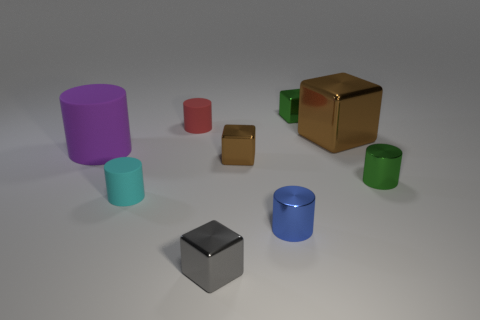What shape is the small metallic thing that is the same color as the big shiny cube?
Your response must be concise. Cube. How many cyan rubber things are the same size as the green cylinder?
Give a very brief answer. 1. Does the thing that is behind the red matte thing have the same size as the tiny cyan object?
Your answer should be compact. Yes. What shape is the tiny object that is left of the blue metallic cylinder and in front of the small cyan rubber object?
Your answer should be compact. Cube. There is a tiny brown metal object; are there any big brown things in front of it?
Ensure brevity in your answer.  No. Is there anything else that has the same shape as the small red thing?
Offer a terse response. Yes. Is the shape of the big brown object the same as the gray thing?
Make the answer very short. Yes. Are there the same number of tiny gray metallic cubes that are behind the cyan object and small brown metallic blocks that are left of the purple rubber cylinder?
Ensure brevity in your answer.  Yes. How many other things are there of the same material as the tiny blue cylinder?
Offer a terse response. 5. What number of large objects are either purple things or cyan rubber cylinders?
Offer a terse response. 1. 